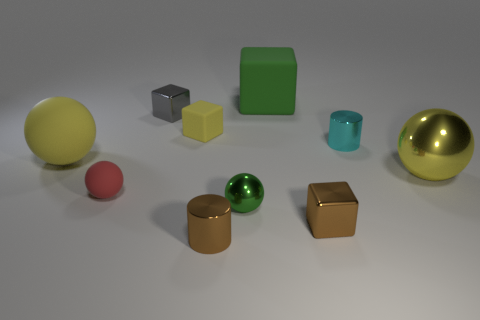Subtract all yellow matte spheres. How many spheres are left? 3 Subtract all red balls. How many balls are left? 3 Subtract 3 balls. How many balls are left? 1 Subtract all spheres. How many objects are left? 6 Subtract all purple cylinders. How many brown cubes are left? 1 Subtract all small cyan metal cylinders. Subtract all small cyan shiny cylinders. How many objects are left? 8 Add 8 green rubber objects. How many green rubber objects are left? 9 Add 7 small rubber blocks. How many small rubber blocks exist? 8 Subtract 0 blue cubes. How many objects are left? 10 Subtract all blue cylinders. Subtract all green balls. How many cylinders are left? 2 